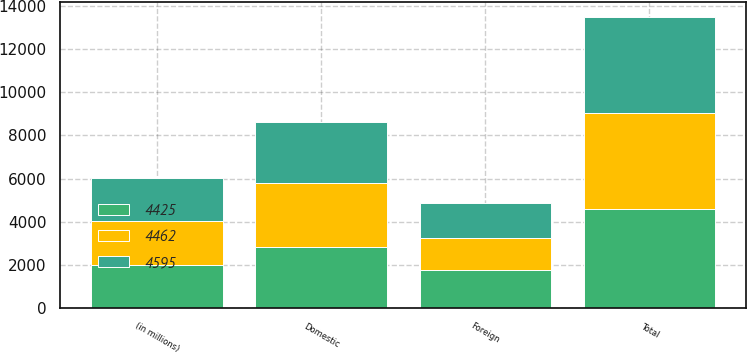Convert chart. <chart><loc_0><loc_0><loc_500><loc_500><stacked_bar_chart><ecel><fcel>(in millions)<fcel>Domestic<fcel>Foreign<fcel>Total<nl><fcel>4595<fcel>2016<fcel>2837<fcel>1625<fcel>4462<nl><fcel>4425<fcel>2015<fcel>2840<fcel>1755<fcel>4595<nl><fcel>4462<fcel>2014<fcel>2946<fcel>1479<fcel>4425<nl></chart> 